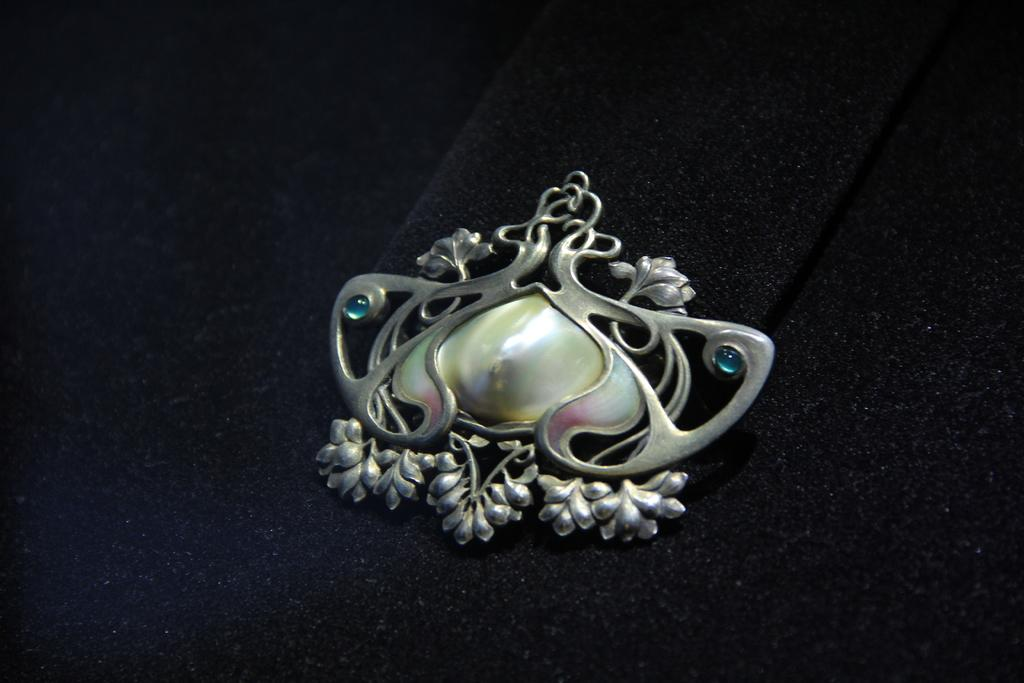What is the main object in the image? There is a pendant in the image. What is the pendant placed on? The pendant is on a black color surface. What type of print can be seen on the hand in the image? There is no hand or print present in the image; it only features a pendant on a black surface. 